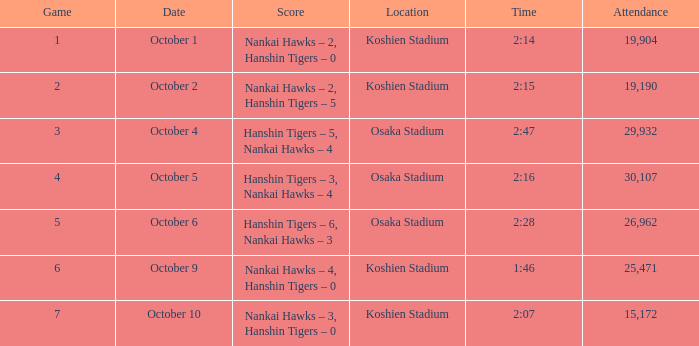How many games had a Time of 2:14? 1.0. 